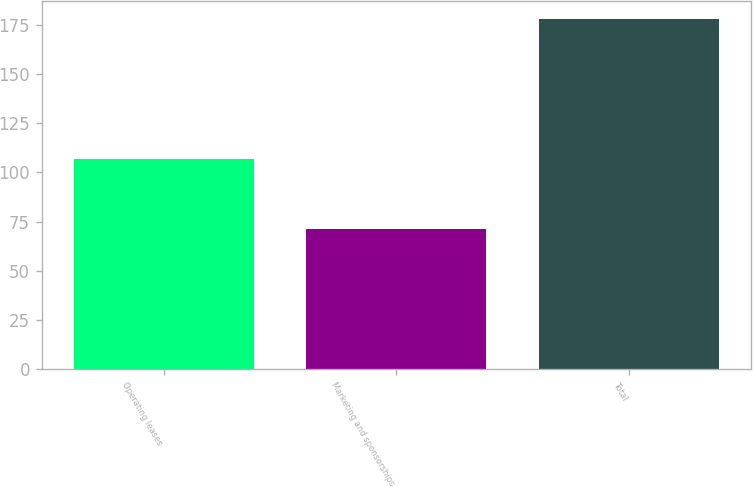<chart> <loc_0><loc_0><loc_500><loc_500><bar_chart><fcel>Operating leases<fcel>Marketing and sponsorships<fcel>Total<nl><fcel>107<fcel>71<fcel>178<nl></chart> 